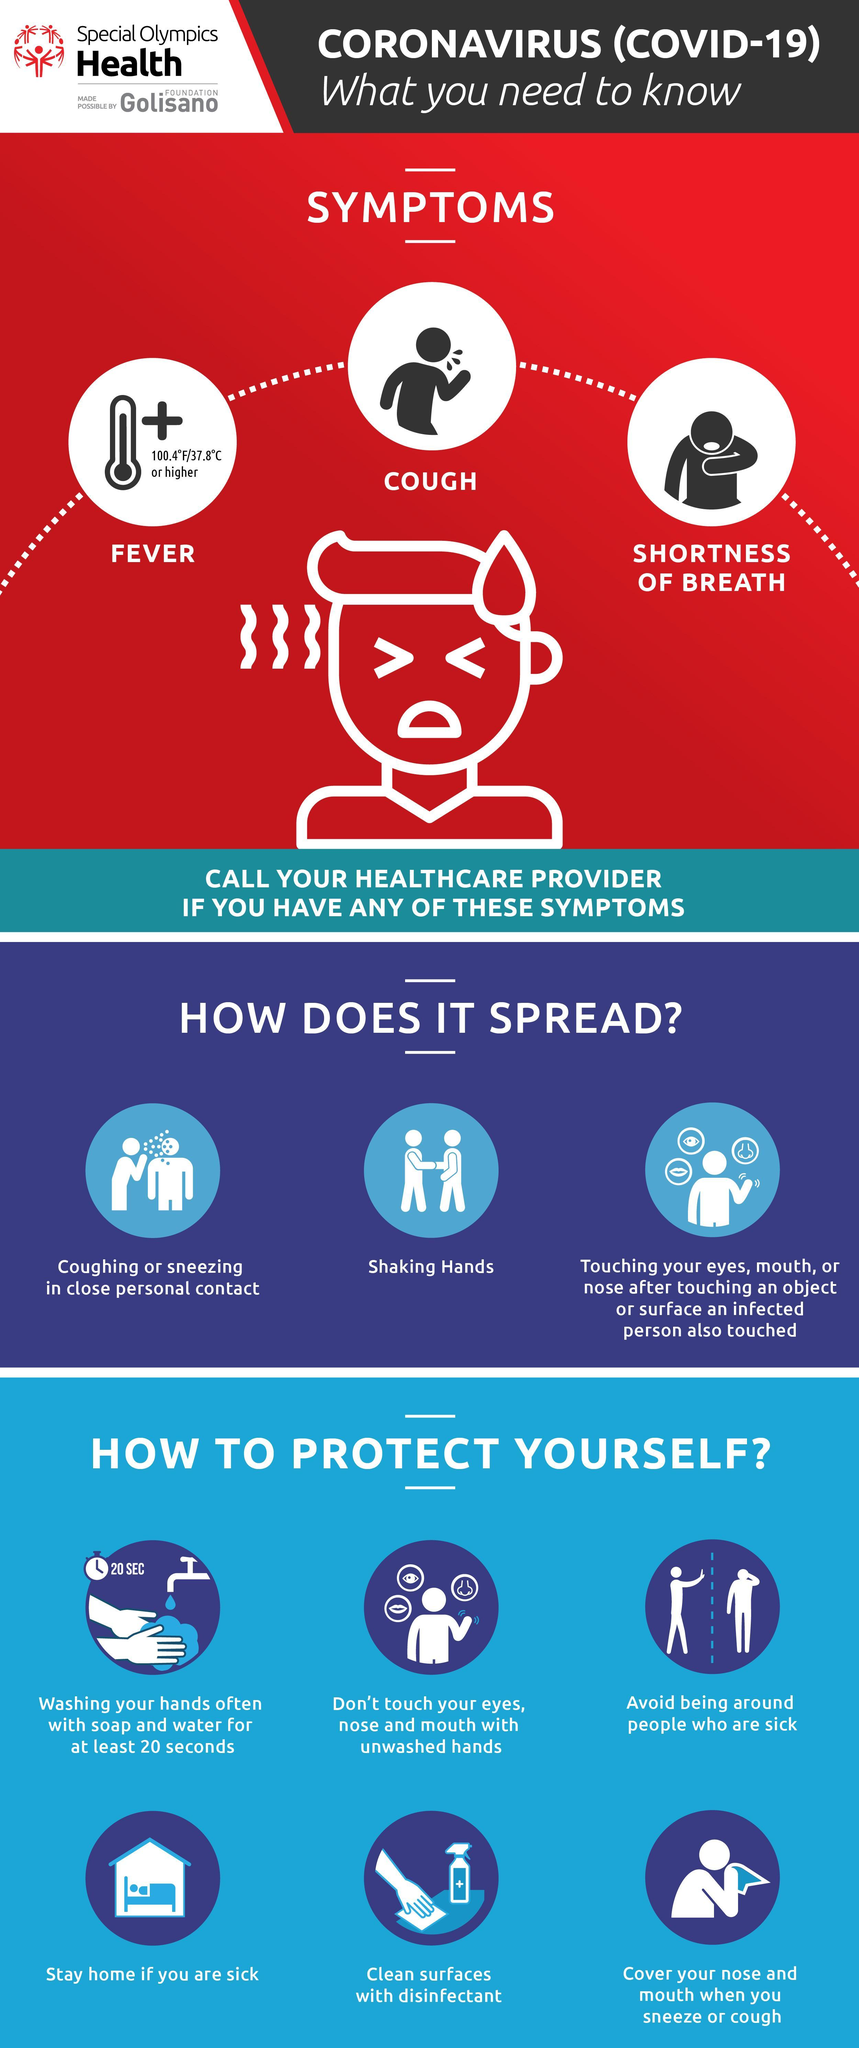How many ways to protect ourselves
Answer the question with a short phrase. 6 what should be used to clean surface disinfectant What are the symptoms of COVID-19 Fever, Cough, Shortness of Breath What number is written in the image with a tap and hand 20 How long should we wash our hands with soap and water 20 seconds 